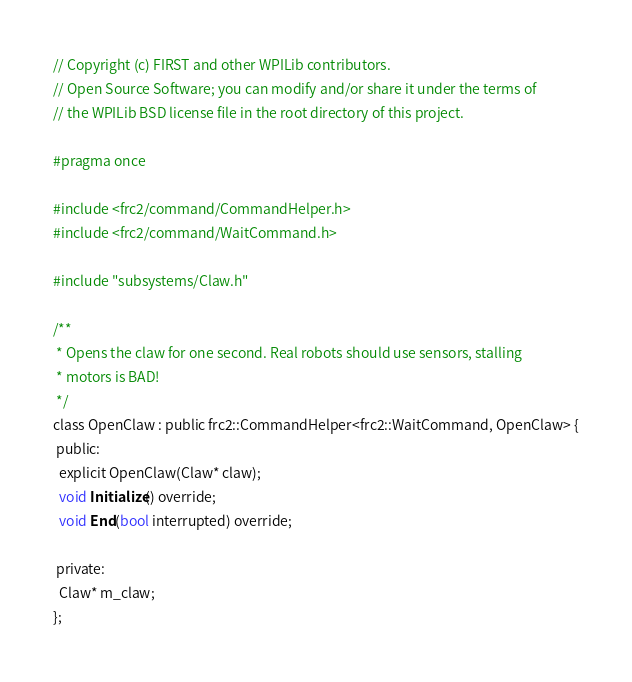Convert code to text. <code><loc_0><loc_0><loc_500><loc_500><_C_>// Copyright (c) FIRST and other WPILib contributors.
// Open Source Software; you can modify and/or share it under the terms of
// the WPILib BSD license file in the root directory of this project.

#pragma once

#include <frc2/command/CommandHelper.h>
#include <frc2/command/WaitCommand.h>

#include "subsystems/Claw.h"

/**
 * Opens the claw for one second. Real robots should use sensors, stalling
 * motors is BAD!
 */
class OpenClaw : public frc2::CommandHelper<frc2::WaitCommand, OpenClaw> {
 public:
  explicit OpenClaw(Claw* claw);
  void Initialize() override;
  void End(bool interrupted) override;

 private:
  Claw* m_claw;
};
</code> 